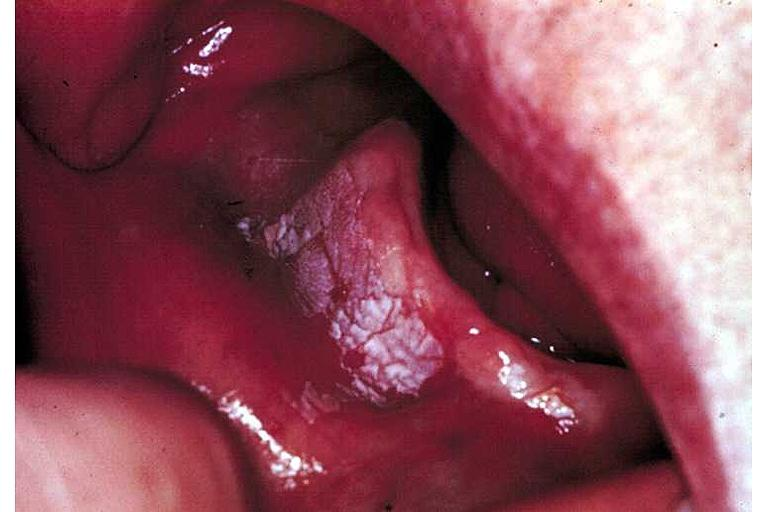what is present?
Answer the question using a single word or phrase. Oral 